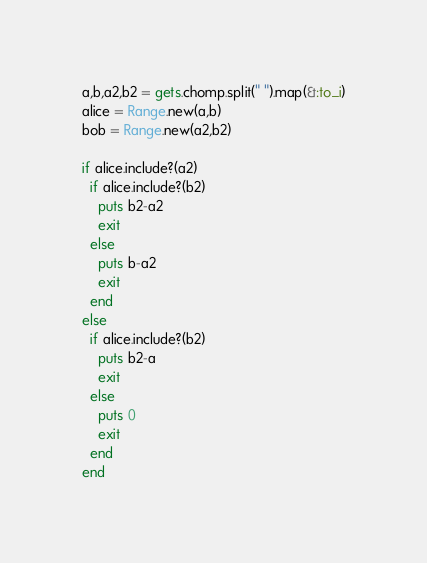Convert code to text. <code><loc_0><loc_0><loc_500><loc_500><_Ruby_>a,b,a2,b2 = gets.chomp.split(" ").map(&:to_i)
alice = Range.new(a,b)
bob = Range.new(a2,b2)

if alice.include?(a2)
  if alice.include?(b2)
    puts b2-a2
    exit
  else
    puts b-a2
    exit
  end
else
  if alice.include?(b2)
    puts b2-a
    exit
  else
    puts 0
    exit
  end
end</code> 